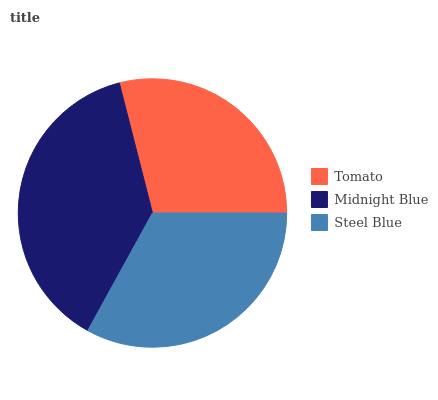Is Tomato the minimum?
Answer yes or no. Yes. Is Midnight Blue the maximum?
Answer yes or no. Yes. Is Steel Blue the minimum?
Answer yes or no. No. Is Steel Blue the maximum?
Answer yes or no. No. Is Midnight Blue greater than Steel Blue?
Answer yes or no. Yes. Is Steel Blue less than Midnight Blue?
Answer yes or no. Yes. Is Steel Blue greater than Midnight Blue?
Answer yes or no. No. Is Midnight Blue less than Steel Blue?
Answer yes or no. No. Is Steel Blue the high median?
Answer yes or no. Yes. Is Steel Blue the low median?
Answer yes or no. Yes. Is Tomato the high median?
Answer yes or no. No. Is Tomato the low median?
Answer yes or no. No. 